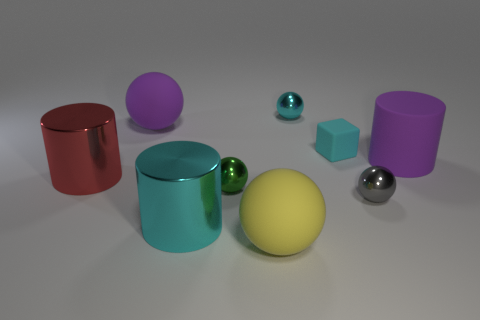There is a gray metallic thing; is its size the same as the purple rubber object that is on the left side of the tiny rubber thing?
Offer a very short reply. No. Is the number of big metal objects that are behind the tiny cyan ball less than the number of tiny cyan things?
Your response must be concise. Yes. What material is the purple thing that is the same shape as the large red object?
Your answer should be very brief. Rubber. There is a cyan object that is both behind the red metallic thing and in front of the tiny cyan metal ball; what shape is it?
Your response must be concise. Cube. What shape is the big yellow thing that is made of the same material as the purple sphere?
Your answer should be very brief. Sphere. There is a large cylinder that is to the right of the green object; what material is it?
Provide a succinct answer. Rubber. There is a purple object that is to the left of the large rubber cylinder; is its size the same as the cyan rubber block behind the large cyan thing?
Provide a short and direct response. No. The tiny cube is what color?
Your answer should be compact. Cyan. Do the tiny thing behind the large purple matte sphere and the small gray object have the same shape?
Ensure brevity in your answer.  Yes. What material is the large cyan thing?
Keep it short and to the point. Metal. 